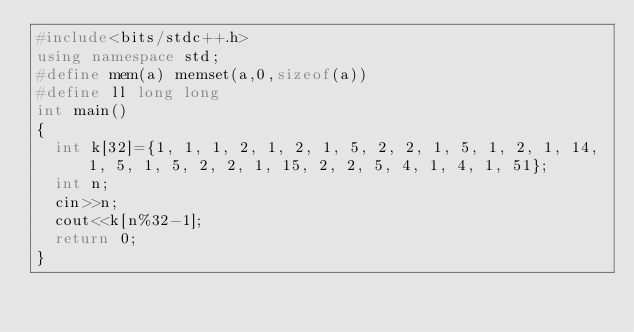Convert code to text. <code><loc_0><loc_0><loc_500><loc_500><_C++_>#include<bits/stdc++.h>
using namespace std;
#define mem(a) memset(a,0,sizeof(a))
#define ll long long
int main()
{
	int k[32]={1, 1, 1, 2, 1, 2, 1, 5, 2, 2, 1, 5, 1, 2, 1, 14, 1, 5, 1, 5, 2, 2, 1, 15, 2, 2, 5, 4, 1, 4, 1, 51};
	int n;
	cin>>n;
	cout<<k[n%32-1];
	return 0;
}</code> 